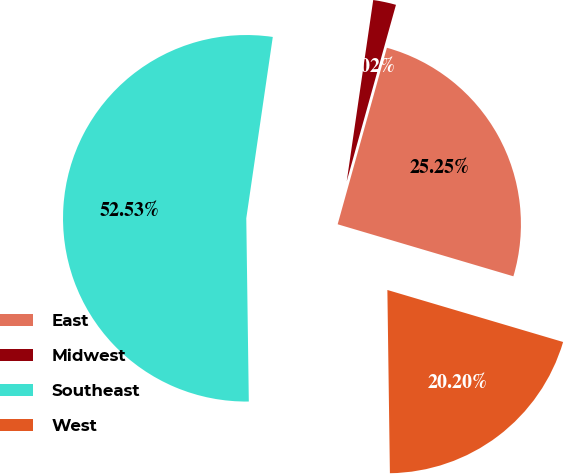<chart> <loc_0><loc_0><loc_500><loc_500><pie_chart><fcel>East<fcel>Midwest<fcel>Southeast<fcel>West<nl><fcel>25.25%<fcel>2.02%<fcel>52.53%<fcel>20.2%<nl></chart> 